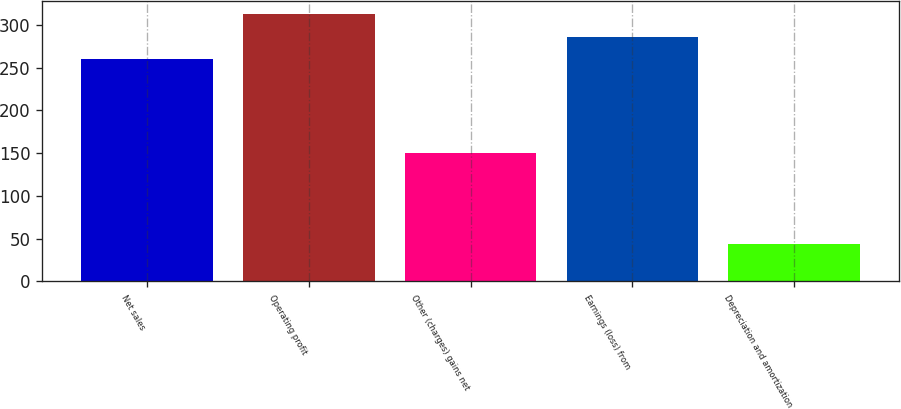Convert chart to OTSL. <chart><loc_0><loc_0><loc_500><loc_500><bar_chart><fcel>Net sales<fcel>Operating profit<fcel>Other (charges) gains net<fcel>Earnings (loss) from<fcel>Depreciation and amortization<nl><fcel>260<fcel>312.6<fcel>150<fcel>286.3<fcel>44<nl></chart> 